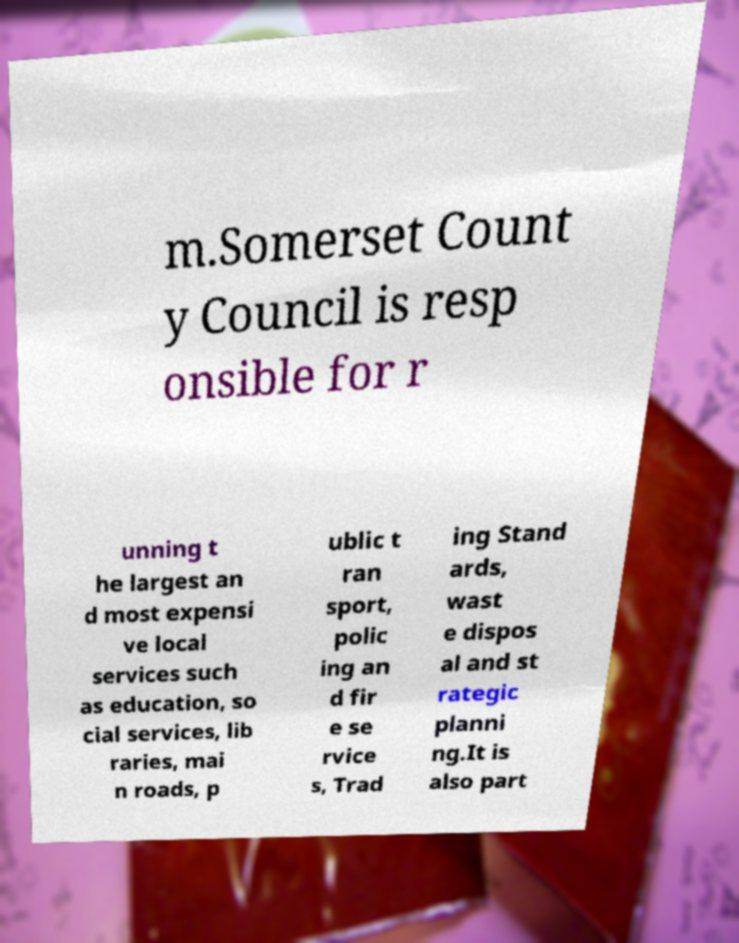Can you accurately transcribe the text from the provided image for me? m.Somerset Count y Council is resp onsible for r unning t he largest an d most expensi ve local services such as education, so cial services, lib raries, mai n roads, p ublic t ran sport, polic ing an d fir e se rvice s, Trad ing Stand ards, wast e dispos al and st rategic planni ng.It is also part 